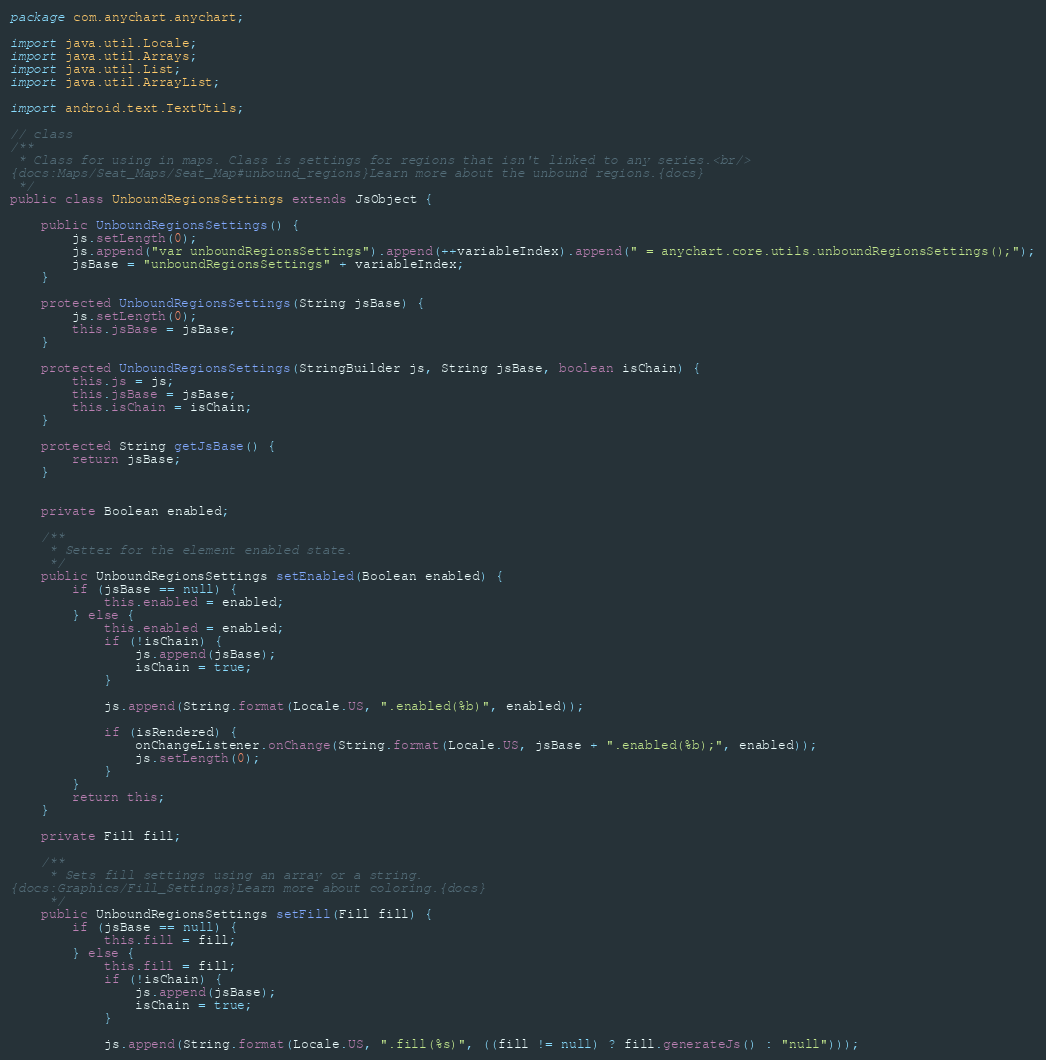Convert code to text. <code><loc_0><loc_0><loc_500><loc_500><_Java_>package com.anychart.anychart;

import java.util.Locale;
import java.util.Arrays;
import java.util.List;
import java.util.ArrayList;

import android.text.TextUtils;

// class
/**
 * Class for using in maps. Class is settings for regions that isn't linked to any series.<br/>
{docs:Maps/Seat_Maps/Seat_Map#unbound_regions}Learn more about the unbound regions.{docs}
 */
public class UnboundRegionsSettings extends JsObject {

    public UnboundRegionsSettings() {
        js.setLength(0);
        js.append("var unboundRegionsSettings").append(++variableIndex).append(" = anychart.core.utils.unboundRegionsSettings();");
        jsBase = "unboundRegionsSettings" + variableIndex;
    }

    protected UnboundRegionsSettings(String jsBase) {
        js.setLength(0);
        this.jsBase = jsBase;
    }

    protected UnboundRegionsSettings(StringBuilder js, String jsBase, boolean isChain) {
        this.js = js;
        this.jsBase = jsBase;
        this.isChain = isChain;
    }

    protected String getJsBase() {
        return jsBase;
    }

    
    private Boolean enabled;

    /**
     * Setter for the element enabled state.
     */
    public UnboundRegionsSettings setEnabled(Boolean enabled) {
        if (jsBase == null) {
            this.enabled = enabled;
        } else {
            this.enabled = enabled;
            if (!isChain) {
                js.append(jsBase);
                isChain = true;
            }
            
            js.append(String.format(Locale.US, ".enabled(%b)", enabled));

            if (isRendered) {
                onChangeListener.onChange(String.format(Locale.US, jsBase + ".enabled(%b);", enabled));
                js.setLength(0);
            }
        }
        return this;
    }

    private Fill fill;

    /**
     * Sets fill settings using an array or a string.
{docs:Graphics/Fill_Settings}Learn more about coloring.{docs}
     */
    public UnboundRegionsSettings setFill(Fill fill) {
        if (jsBase == null) {
            this.fill = fill;
        } else {
            this.fill = fill;
            if (!isChain) {
                js.append(jsBase);
                isChain = true;
            }
            
            js.append(String.format(Locale.US, ".fill(%s)", ((fill != null) ? fill.generateJs() : "null")));
</code> 